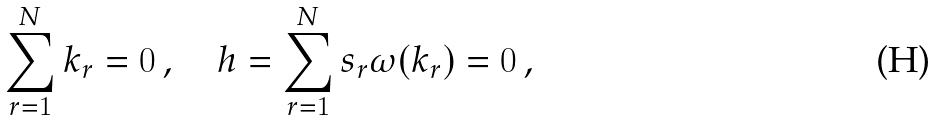<formula> <loc_0><loc_0><loc_500><loc_500>\sum _ { r = 1 } ^ { N } { k } _ { r } = 0 \, , \quad h = \sum _ { r = 1 } ^ { N } s _ { r } \omega ( { k } _ { r } ) = 0 \, ,</formula> 